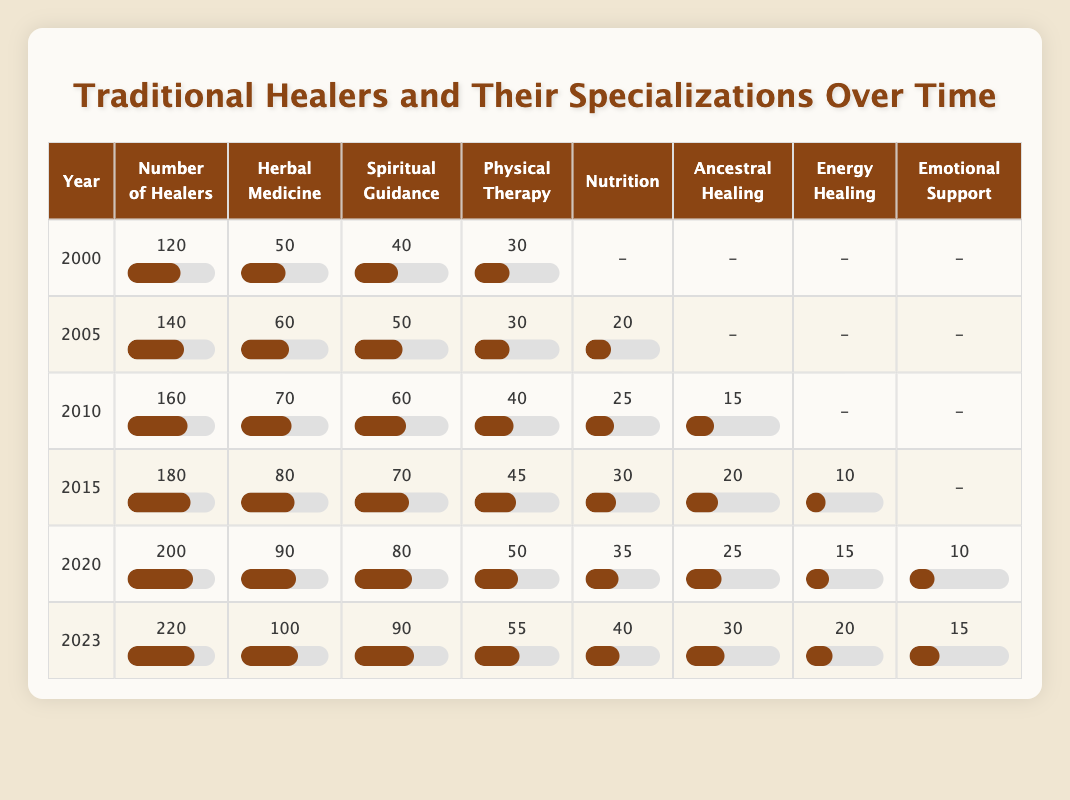What was the total number of traditional healers in 2010? In the table, for the year 2010, the number of traditional healers is stated directly. The value is 160.
Answer: 160 How many specializations were reported in 2005? In the table for 2005, there are five specializations listed: herbal medicine, spiritual guidance, physical therapy, nutrition, and energy healing. Hence the total number of specializations is 5.
Answer: 5 What is the average number of herbal medicine practitioners from 2000 to 2023? The number of herbal medicine practitioners from the years 2000, 2005, 2010, 2015, 2020, and 2023 are 50, 60, 70, 80, 90, and 100 respectively. To find the average, add these values (50 + 60 + 70 + 80 + 90 + 100 = 450) and divide by the number of years (6). So, the average is 450/6 = 75.
Answer: 75 Was the number of traditional healers greater in 2020 than in 2005? In the table, the number of traditional healers in 2020 is 200 and in 2005 it is 140. Since 200 is greater than 140, the statement is true.
Answer: Yes How much did the number of physical therapy practitioners increase from 2010 to 2023? In 2010, the number of physical therapy practitioners is 40 and in 2023 it is 55. To find the increase, subtract the former value from the latter (55 - 40 = 15). Thus, there is an increase of 15 practitioners.
Answer: 15 What year had the highest number of spiritual guidance practitioners, and how many were there? By examining the table, the year with the highest number of spiritual guidance practitioners is 2023, where the number is 90. So, the answer consists of the year and the value.
Answer: 2023, 90 Was there a specialization in emotional support in the year 2000? Looking at the year 2000 in the table, emotional support is not listed among the specializations. Thus, the answer is no.
Answer: No If we consider the total number of traditional healers from 2000 to 2023, what is the percentage increase from the year 2000 to 2023? The number of traditional healers in 2000 is 120 and in 2023 it is 220. First, calculate the increase (220 - 120 = 100), then divide by the original number (100/120 = 0.8333), and multiply by 100 to get the percentage, which is approximately 83.33%.
Answer: 83.33% 